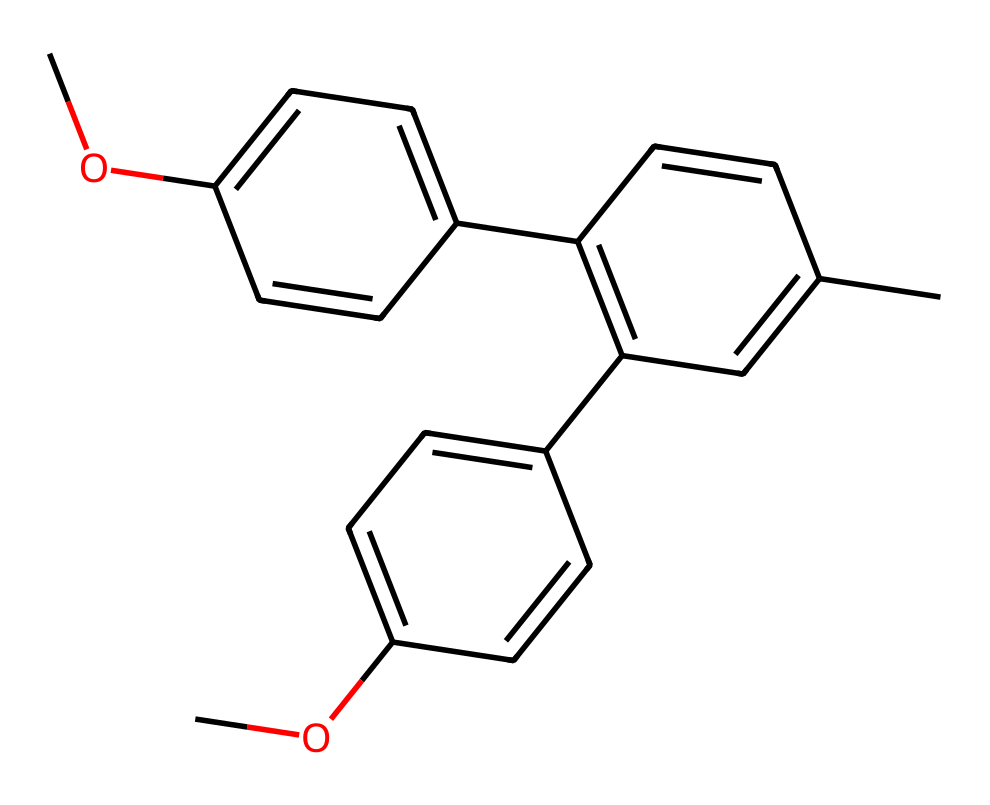What is the total number of carbon atoms in this compound? By examining the SMILES representation, we can count the 'C' characters, which represent carbon atoms. In this case, there are 18 carbon atoms in total throughout the entire structure.
Answer: 18 How many methoxy groups (-OCH3) are present in this molecule? In the chemical structure, we can identify the methoxy groups by looking for 'OC' or 'OCH3' motifs. In this case, there are two methoxy groups as indicated by their positions in the SMILES representation.
Answer: 2 What type of functional group is predominantly featured in this chemical? Analyzing the chemical structure, we can see that it contains several aromatic rings, indicating that the predominant functional group is aromatic. The presence of multiple 'C' connections forming these rings supports this classification.
Answer: aromatic How many double bonds are in the structure? The presence of '=' signs in the SMILES string indicates double bonds. By counting the pairs of connected carbons with '=' between them throughout the compound, we find there are 5 double bonds.
Answer: 5 What is the main class of this monomer? The structure shows multiple aromatic systems and substituents, which are indicative of the class of monomers known as polyphenols. This classification is based on the repeating phenolic unit observed in the chemical structure.
Answer: polyphenol Can this chemical block blue light effectively? Considering the presence of conjugated pi systems from the aromatic rings, which is typical for compounds that absorb light in the blue spectrum, it suggests that this compound can block blue light effectively.
Answer: yes 